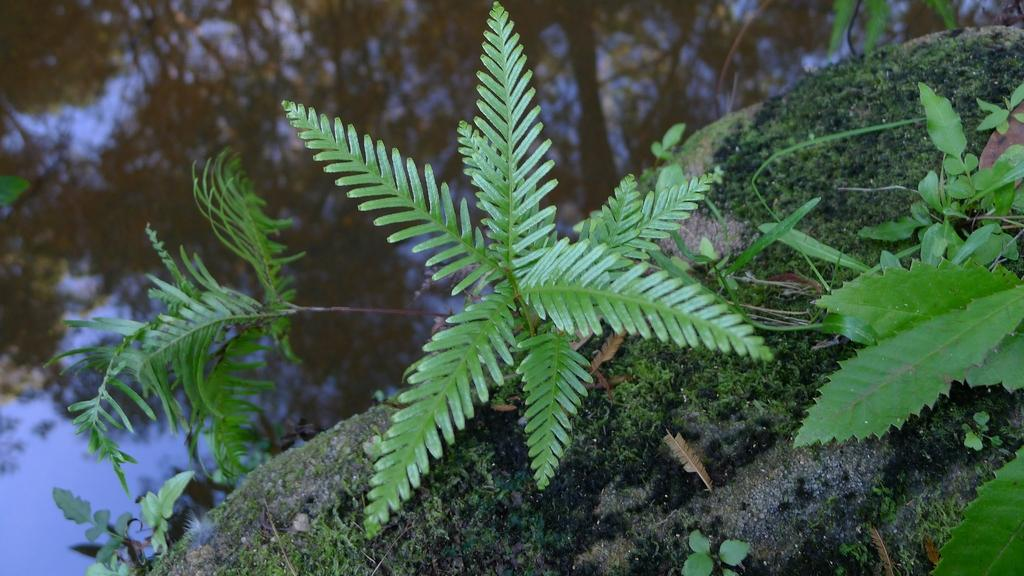What type of living organisms can be seen in the image? Plants can be seen in the image. What is visible at the bottom of the image? There is ground visible at the bottom of the image. What type of weather condition is depicted on the right side of the image? There is snow on the right side of the image. What type of paste is being used to create motion in the image? There is no paste or motion present in the image; it is a still image of plants, ground, and snow. 